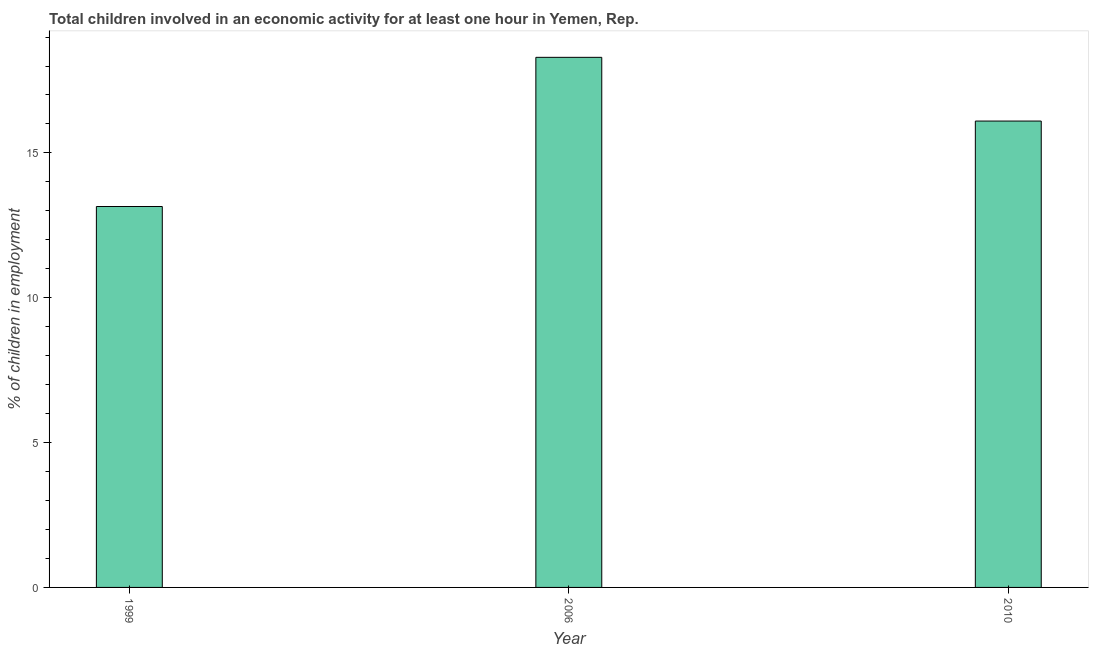Does the graph contain any zero values?
Give a very brief answer. No. What is the title of the graph?
Your answer should be very brief. Total children involved in an economic activity for at least one hour in Yemen, Rep. What is the label or title of the X-axis?
Give a very brief answer. Year. What is the label or title of the Y-axis?
Give a very brief answer. % of children in employment. What is the percentage of children in employment in 2010?
Your answer should be compact. 16.1. Across all years, what is the minimum percentage of children in employment?
Give a very brief answer. 13.15. In which year was the percentage of children in employment maximum?
Your answer should be very brief. 2006. What is the sum of the percentage of children in employment?
Provide a short and direct response. 47.55. What is the difference between the percentage of children in employment in 1999 and 2006?
Offer a terse response. -5.15. What is the average percentage of children in employment per year?
Make the answer very short. 15.85. What is the median percentage of children in employment?
Your response must be concise. 16.1. What is the ratio of the percentage of children in employment in 1999 to that in 2006?
Your response must be concise. 0.72. Is the percentage of children in employment in 1999 less than that in 2006?
Your answer should be very brief. Yes. What is the difference between the highest and the second highest percentage of children in employment?
Keep it short and to the point. 2.2. Is the sum of the percentage of children in employment in 2006 and 2010 greater than the maximum percentage of children in employment across all years?
Provide a succinct answer. Yes. What is the difference between the highest and the lowest percentage of children in employment?
Your response must be concise. 5.15. In how many years, is the percentage of children in employment greater than the average percentage of children in employment taken over all years?
Your answer should be compact. 2. How many years are there in the graph?
Your response must be concise. 3. Are the values on the major ticks of Y-axis written in scientific E-notation?
Provide a succinct answer. No. What is the % of children in employment in 1999?
Give a very brief answer. 13.15. What is the % of children in employment of 2010?
Give a very brief answer. 16.1. What is the difference between the % of children in employment in 1999 and 2006?
Offer a terse response. -5.15. What is the difference between the % of children in employment in 1999 and 2010?
Make the answer very short. -2.95. What is the ratio of the % of children in employment in 1999 to that in 2006?
Your answer should be compact. 0.72. What is the ratio of the % of children in employment in 1999 to that in 2010?
Make the answer very short. 0.82. What is the ratio of the % of children in employment in 2006 to that in 2010?
Offer a very short reply. 1.14. 